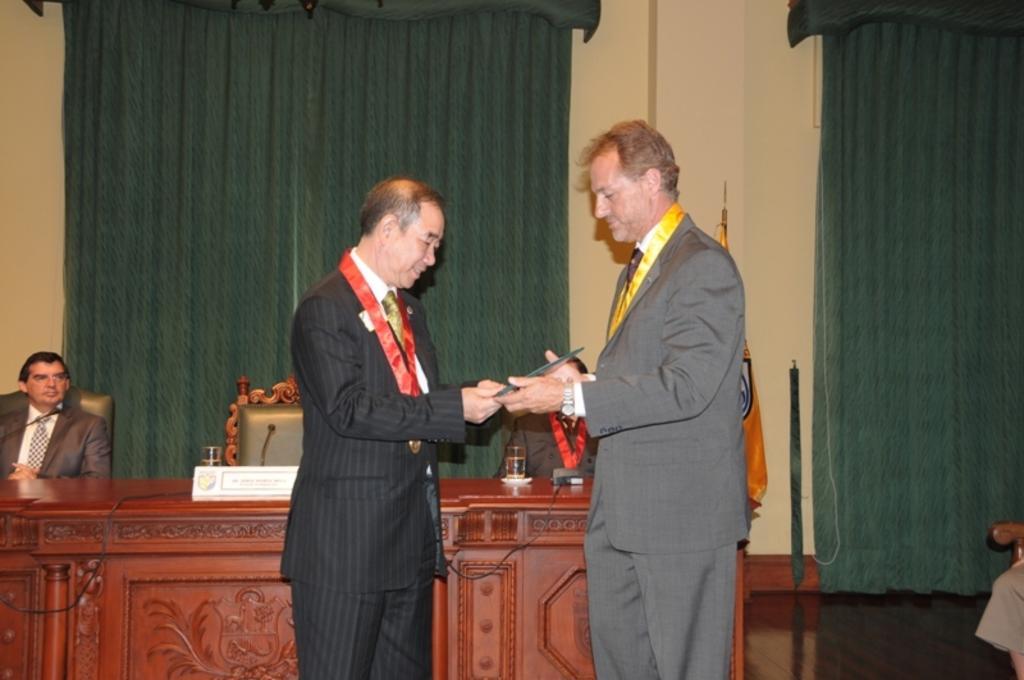How would you summarize this image in a sentence or two? In the picture we can see two men are standing and one man is presenting something to the other, they are in blazers, and the tags and behind them, we can see the desk with some name boards and behind it, we can see some chairs and two people are sitting on it and in the background we can see the wall with two curtains which are green in color. 